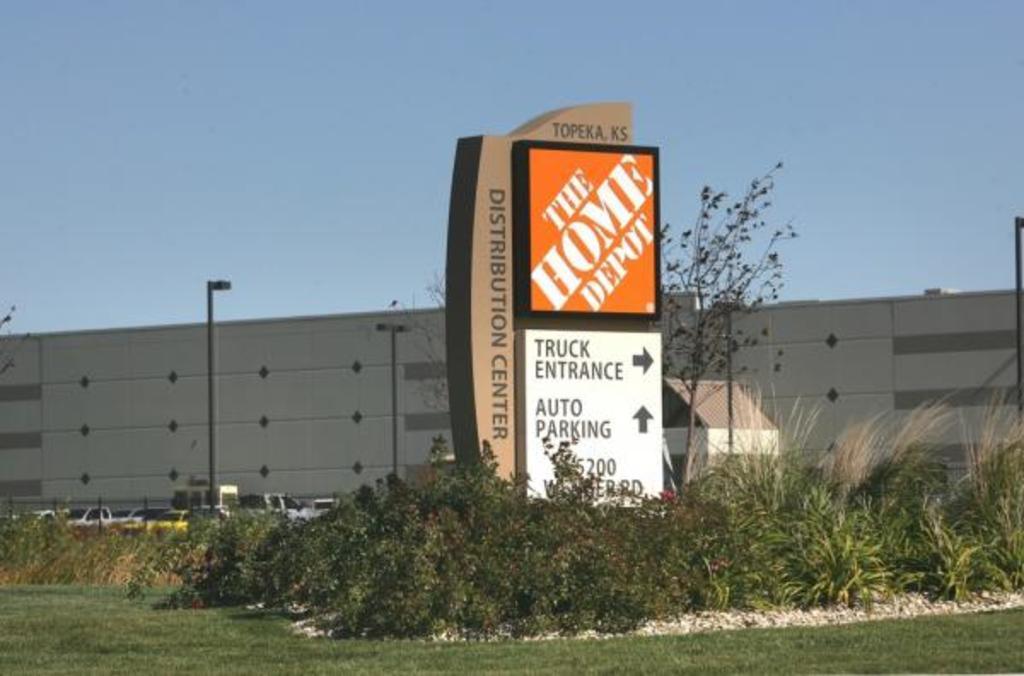How would you summarize this image in a sentence or two? In this picture we can see boards with some text on it, here we can see vehicles, plants, trees, wall and poles and we can see sky in the background. 